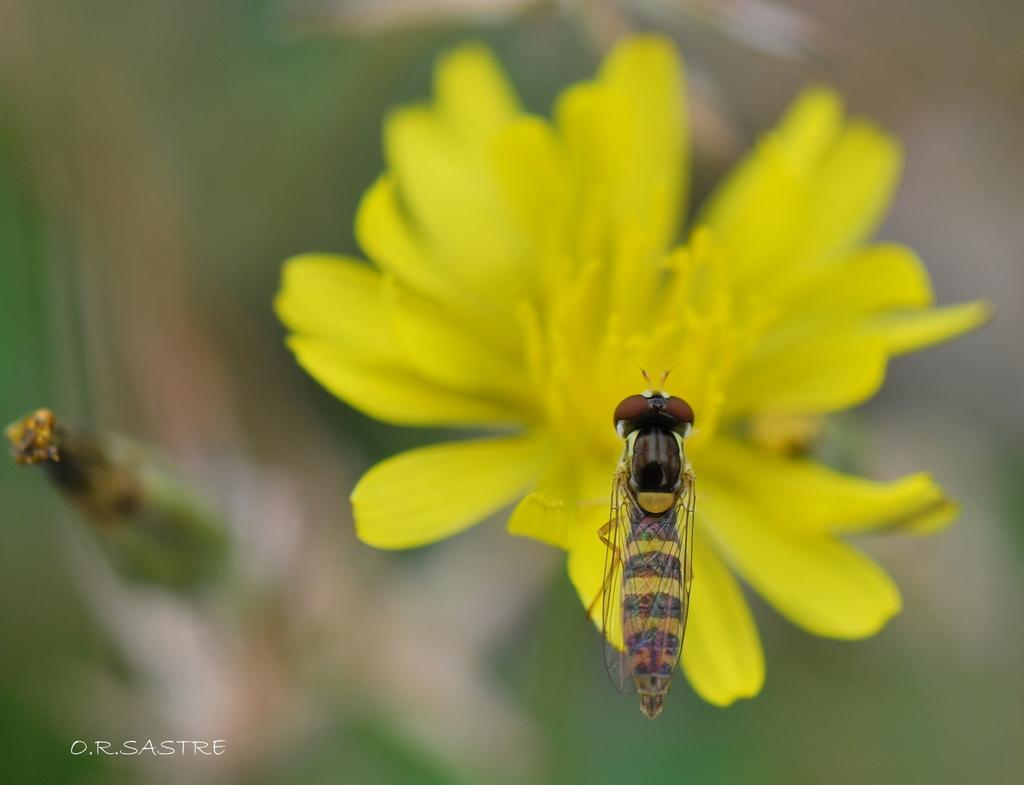What type of flower is in the image? There is a yellow flower in the image. What other living organism can be seen in the image? There is an insect in the image. How would you describe the background of the image? The background of the image is blurred. Is there any text or logo visible in the image? Yes, there is a watermark in the bottom left corner of the image. What type of map is visible in the image? There is no map present in the image. How does the pin interact with the insect in the image? There is no pin present in the image, so it cannot interact with the insect. 